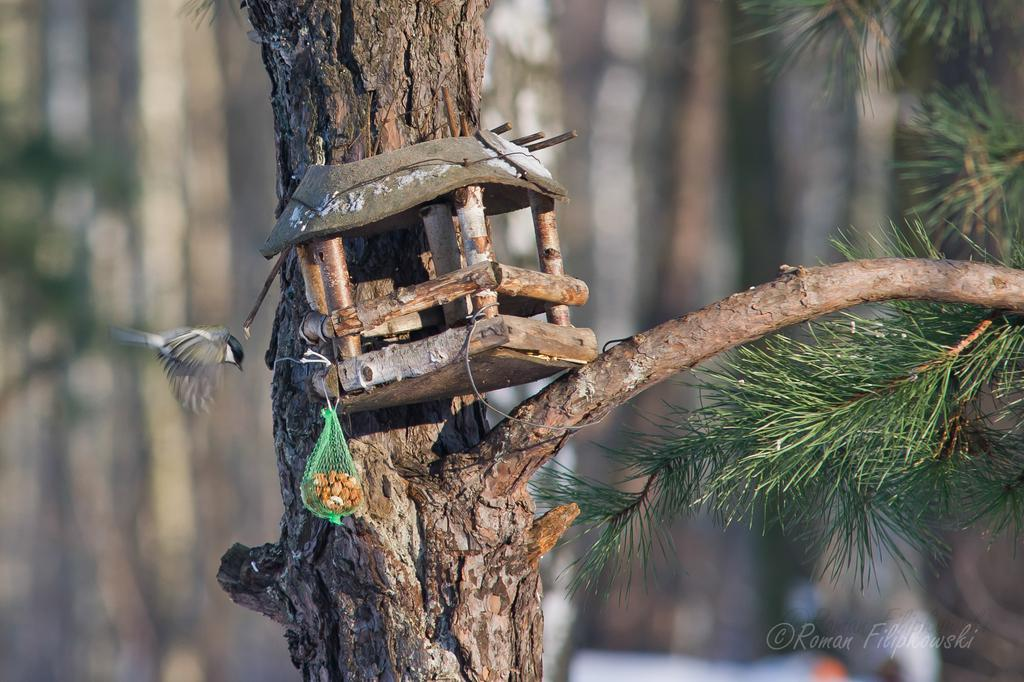What type of natural elements can be seen in the image? There are trees in the image. What type of animal can be seen in the image? There is a bird in the image. What type of food items are present in the image? There are food items in a net in the image. What type of additional information is present in the image? There is text on the image. How would you describe the background of the image? The background of the image is blurred. What type of crime is being committed in the image? There is no indication of any crime being committed in the image. What type of calendar is visible in the image? There is no calendar present in the image. 